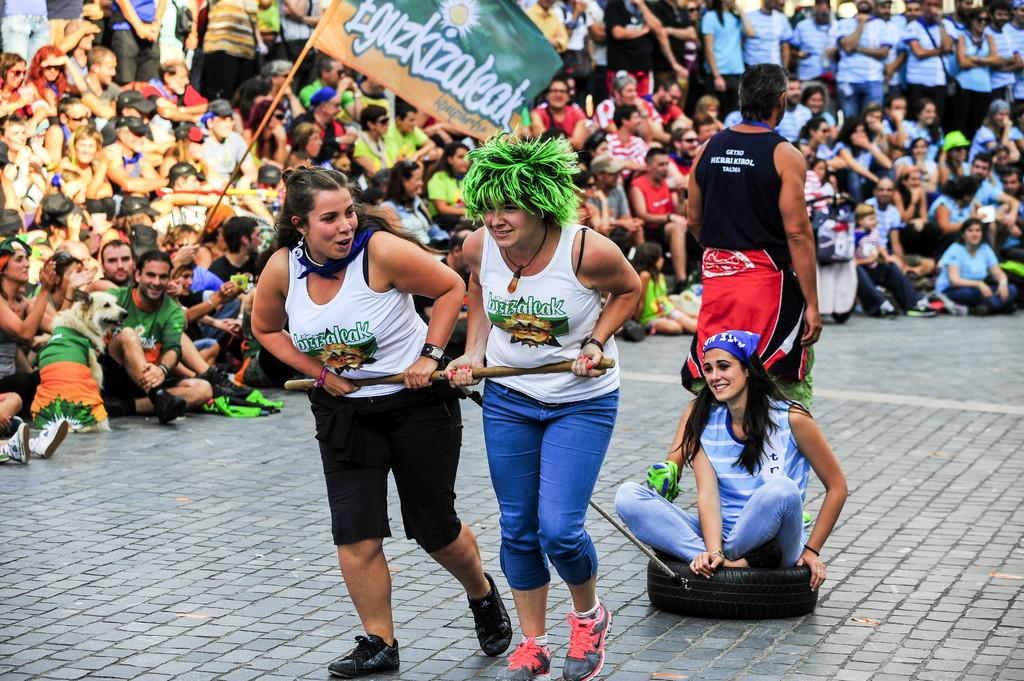What can be seen in the background of the image? There are people in the background of the image. What are the people in the image doing? People are holding an object in the image. What is the lady in the foreground of the image sitting on? The lady is sitting on a tire in the foreground of the image. What type of beast is causing the people in the image to feel shame? There is no beast present in the image, and no one appears to be feeling shame. 